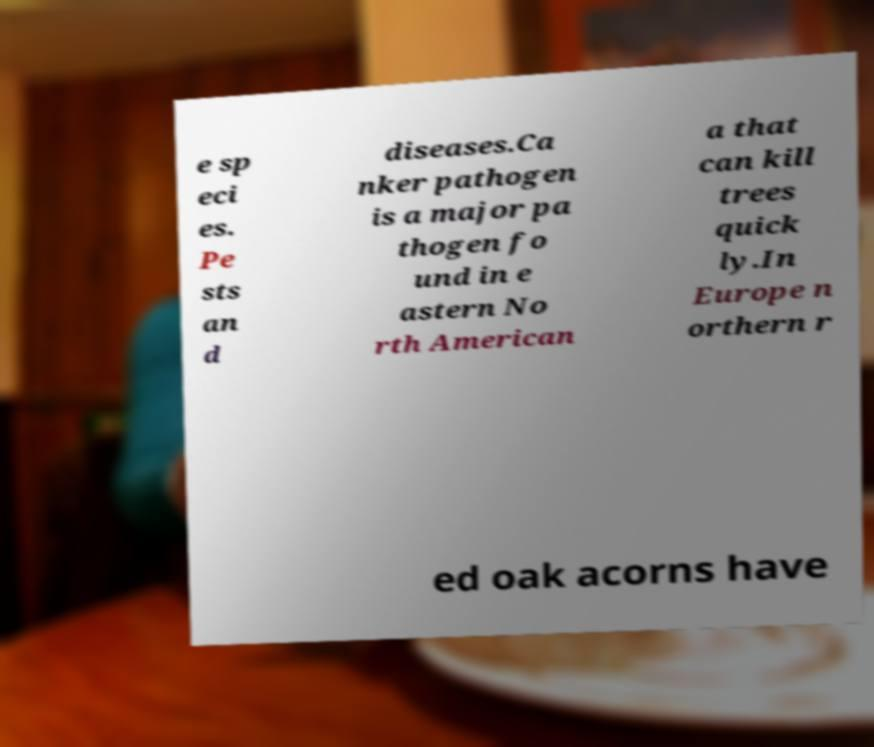Can you accurately transcribe the text from the provided image for me? e sp eci es. Pe sts an d diseases.Ca nker pathogen is a major pa thogen fo und in e astern No rth American a that can kill trees quick ly.In Europe n orthern r ed oak acorns have 